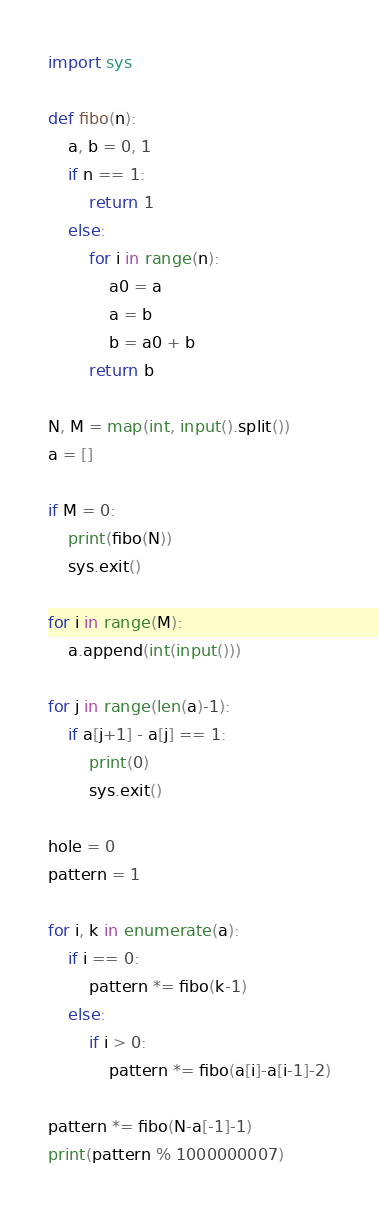Convert code to text. <code><loc_0><loc_0><loc_500><loc_500><_Python_>import sys

def fibo(n):
    a, b = 0, 1
    if n == 1:
        return 1
    else:
        for i in range(n):
            a0 = a
            a = b
            b = a0 + b
        return b
        
N, M = map(int, input().split())
a = []

if M = 0:
    print(fibo(N))
    sys.exit()

for i in range(M):
    a.append(int(input()))
    
for j in range(len(a)-1):
    if a[j+1] - a[j] == 1:
        print(0)
        sys.exit()
    
hole = 0
pattern = 1

for i, k in enumerate(a):
    if i == 0:
        pattern *= fibo(k-1)
    else:
        if i > 0:
            pattern *= fibo(a[i]-a[i-1]-2)
        
pattern *= fibo(N-a[-1]-1)
print(pattern % 1000000007)</code> 